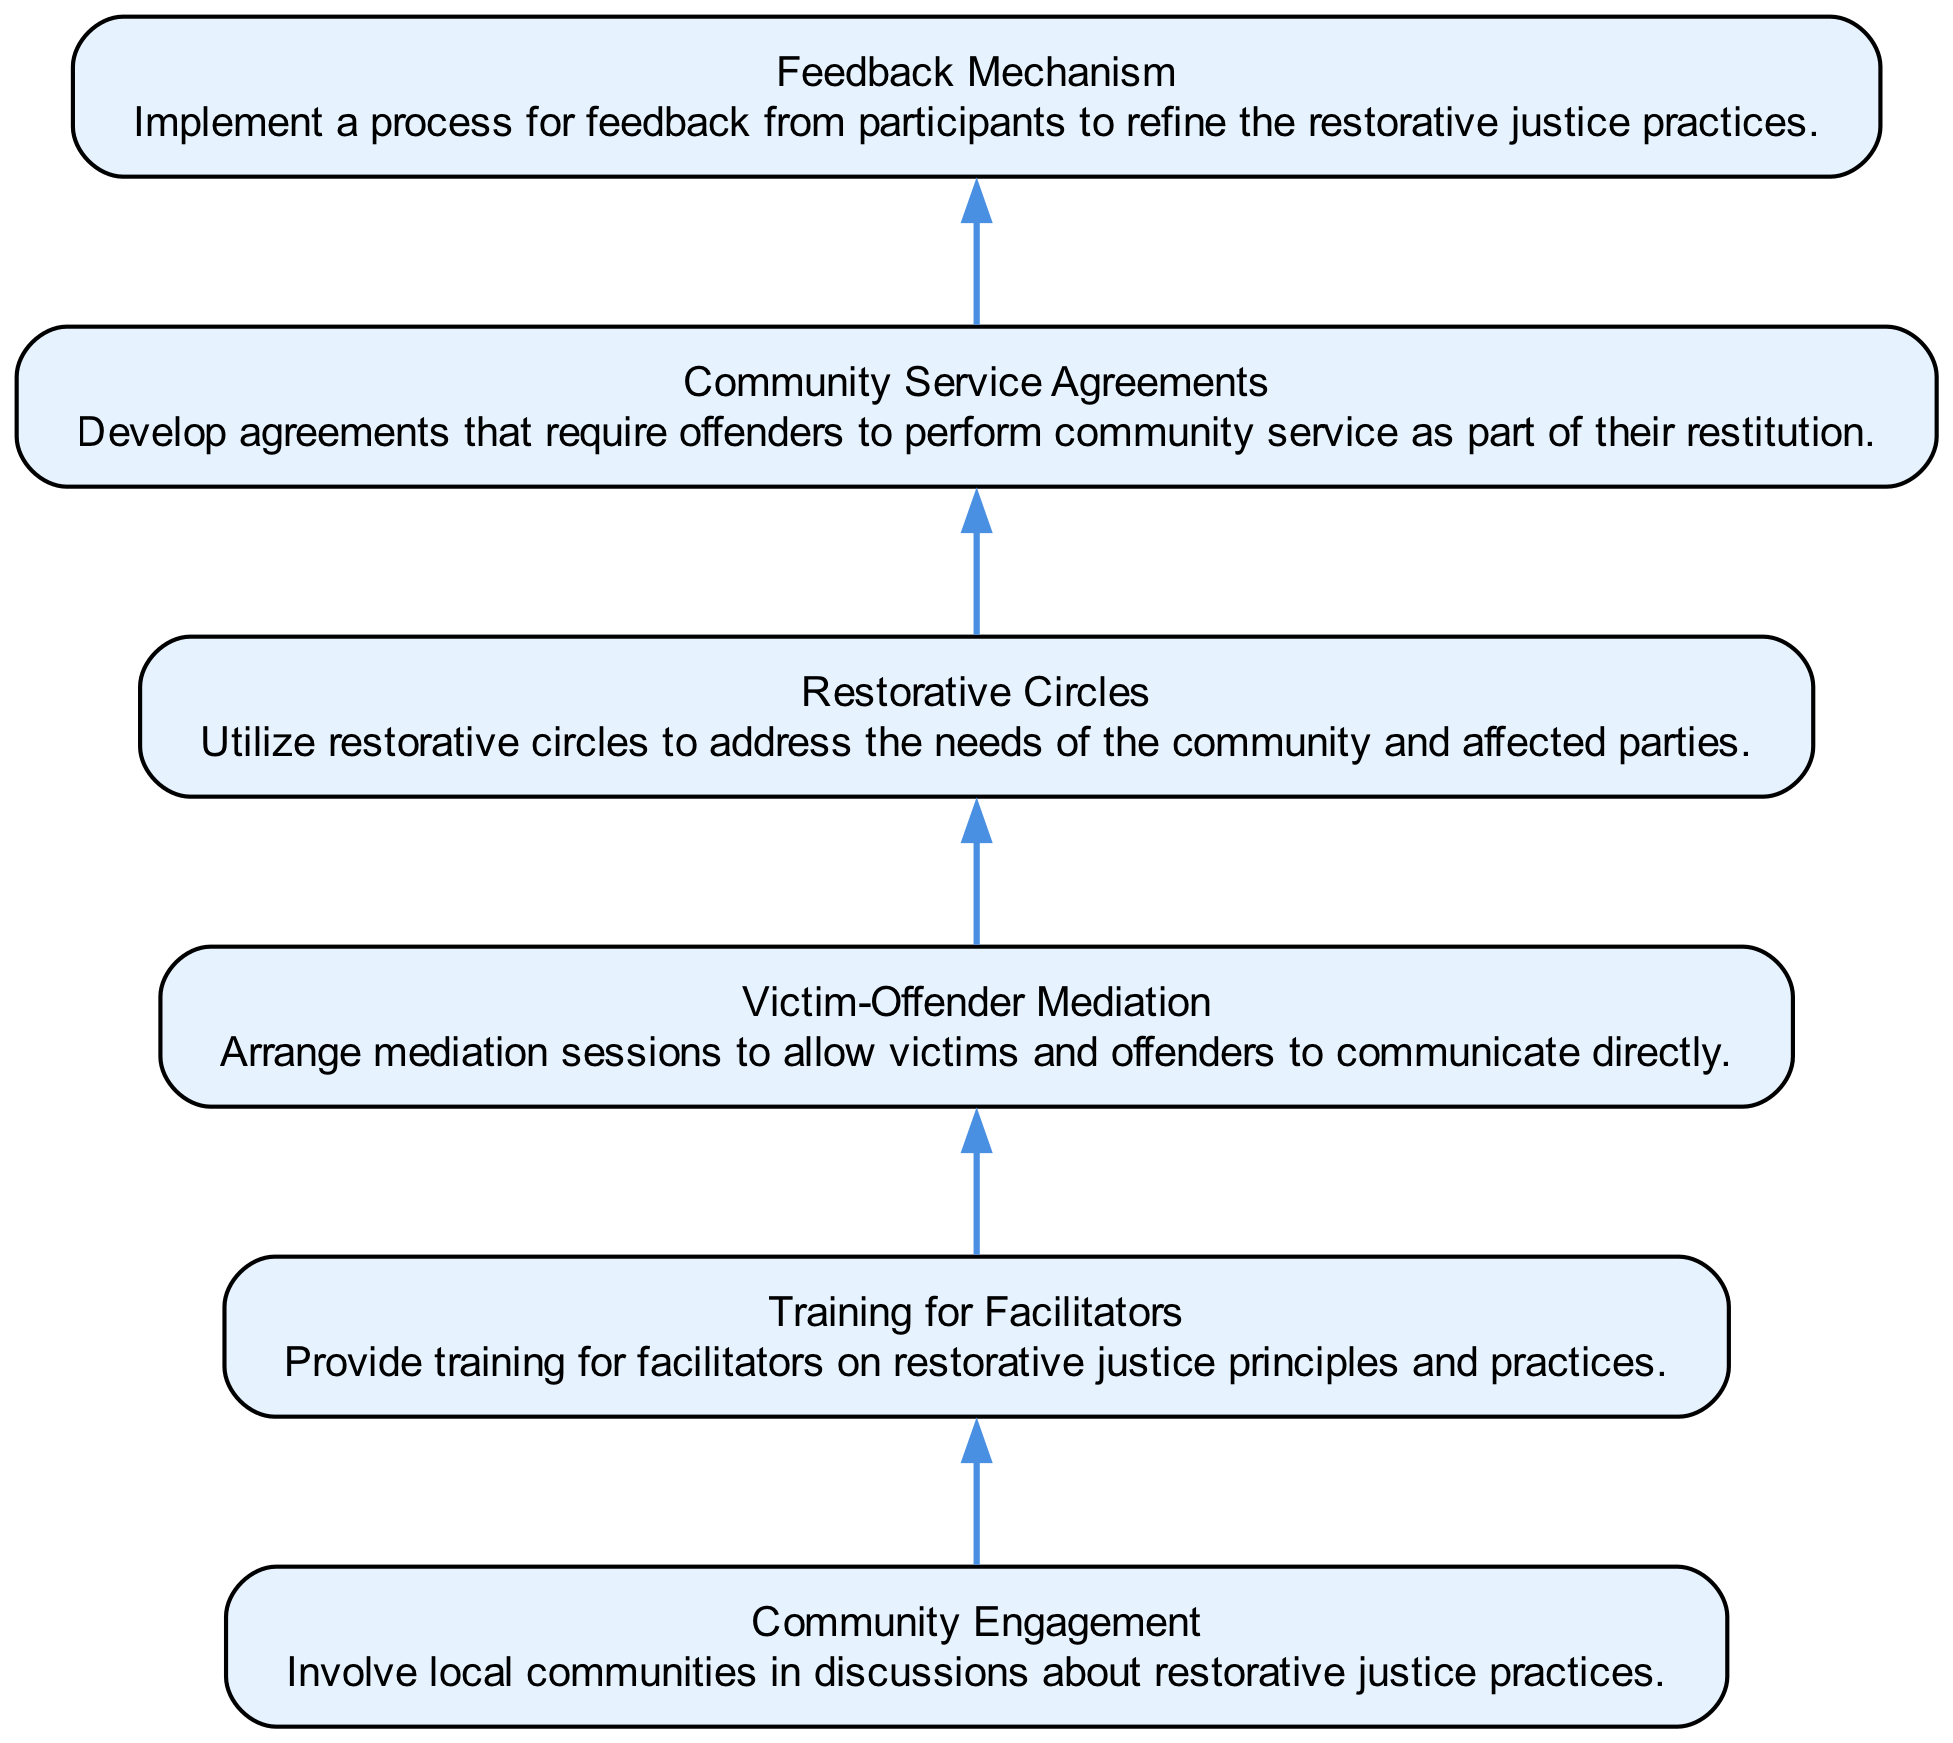What is the first step in the restorative justice practices? The first step is represented by the bottom node in the diagram, which is "Community Engagement." This node initiates the flow of the process by highlighting the importance of local community involvement.
Answer: Community Engagement How many nodes are present in the diagram? By counting each distinct node in the diagram, we find there are six nodes representing different steps in the restorative justice practices.
Answer: 6 What is the last step listed in the diagram? The last step is found at the top of the diagram sequence, which is "Feedback Mechanism," indicating the concluding part of the restorative justice process.
Answer: Feedback Mechanism Which step involves direct communication between victims and offenders? The node labeled "Victim-Offender Mediation" specifically details this step where victims and offenders are allowed to communicate directly, making it the focus of restorative interactions.
Answer: Victim-Offender Mediation What type of agreements are developed as part of community service in the diagram? The diagram specifies "Community Service Agreements," indicating that these agreements are designed to require offenders to perform community service, linking restitution to community engagement.
Answer: Community Service Agreements How many edges are drawn in the diagram? In a flow chart, edges represent the connections between nodes. There are five edges connecting the six nodes, indicating the flow from one practice to the next.
Answer: 5 What approach is used to address community needs in the restorative justice practices? The approach mentioned is "Restorative Circles," which emphasizes addressing the needs of both the community and affected parties through dialogue and mutual understanding.
Answer: Restorative Circles Which step comes immediately before the "Feedback Mechanism"? Tracing the flow backwards in the diagram, the step that precedes the "Feedback Mechanism" is "Community Service Agreements," showing a sequential method of implementation.
Answer: Community Service Agreements What is the primary purpose of the "Training for Facilitators"? The primary purpose is to equip facilitators with knowledge on "restorative justice principles and practices," which is essential for guiding restorative processes effectively.
Answer: Training for Facilitators 